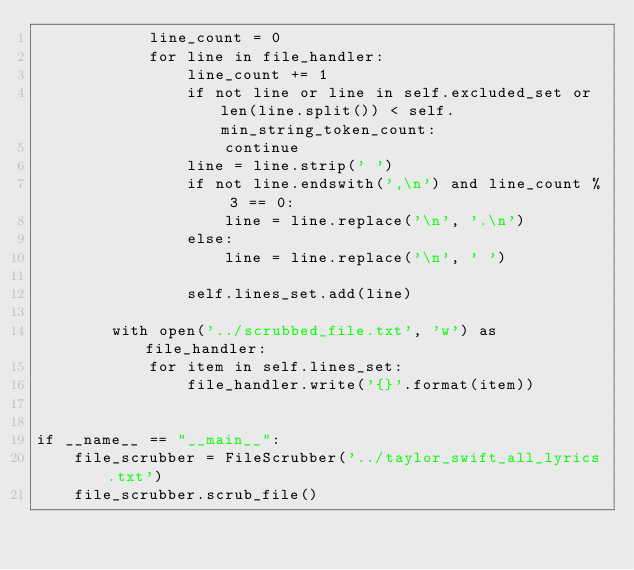Convert code to text. <code><loc_0><loc_0><loc_500><loc_500><_Python_>            line_count = 0
            for line in file_handler:
                line_count += 1
                if not line or line in self.excluded_set or len(line.split()) < self.min_string_token_count:
                    continue
                line = line.strip(' ')
                if not line.endswith(',\n') and line_count % 3 == 0:
                    line = line.replace('\n', '.\n')
                else:
                    line = line.replace('\n', ' ')

                self.lines_set.add(line)

        with open('../scrubbed_file.txt', 'w') as file_handler:
            for item in self.lines_set:
                file_handler.write('{}'.format(item))


if __name__ == "__main__":
    file_scrubber = FileScrubber('../taylor_swift_all_lyrics.txt')
    file_scrubber.scrub_file()
</code> 